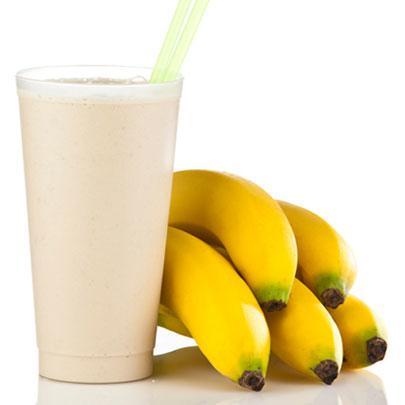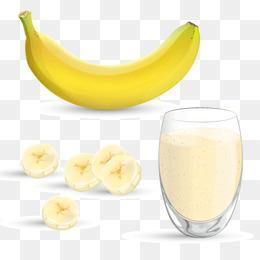The first image is the image on the left, the second image is the image on the right. Evaluate the accuracy of this statement regarding the images: "One of the images has a fruit besides just a banana.". Is it true? Answer yes or no. No. 